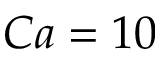<formula> <loc_0><loc_0><loc_500><loc_500>C a = 1 0</formula> 